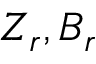<formula> <loc_0><loc_0><loc_500><loc_500>Z _ { r } , B _ { r }</formula> 